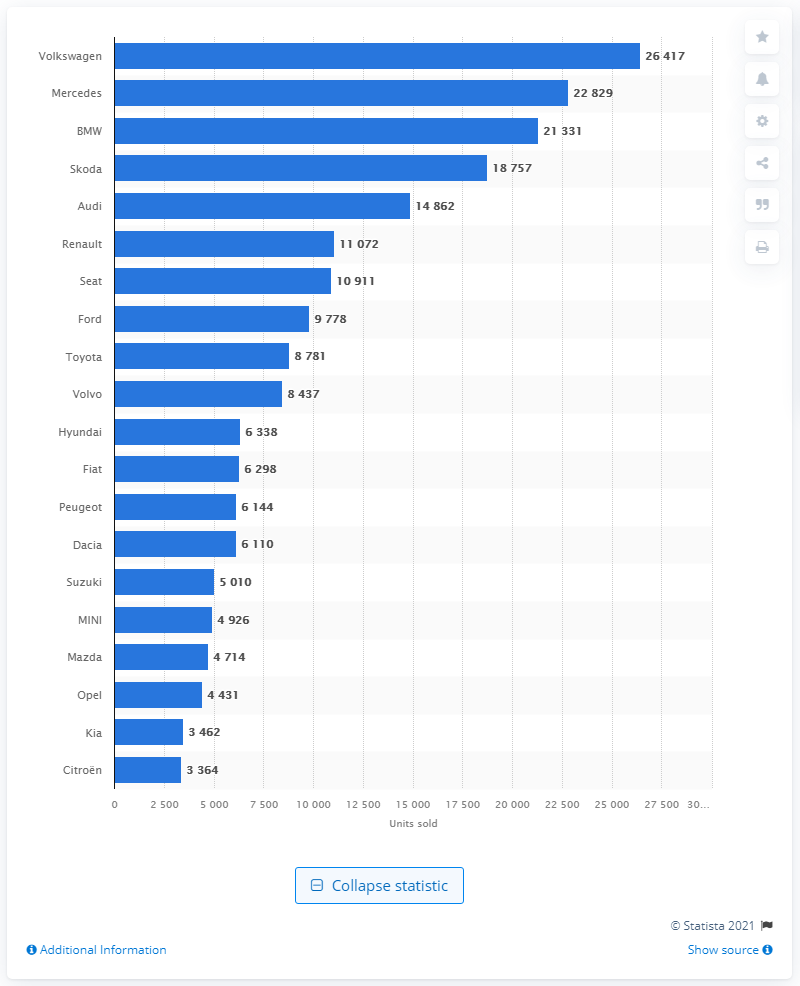Give some essential details in this illustration. Volkswagen was the leading passenger car brand in Switzerland in 2022. 